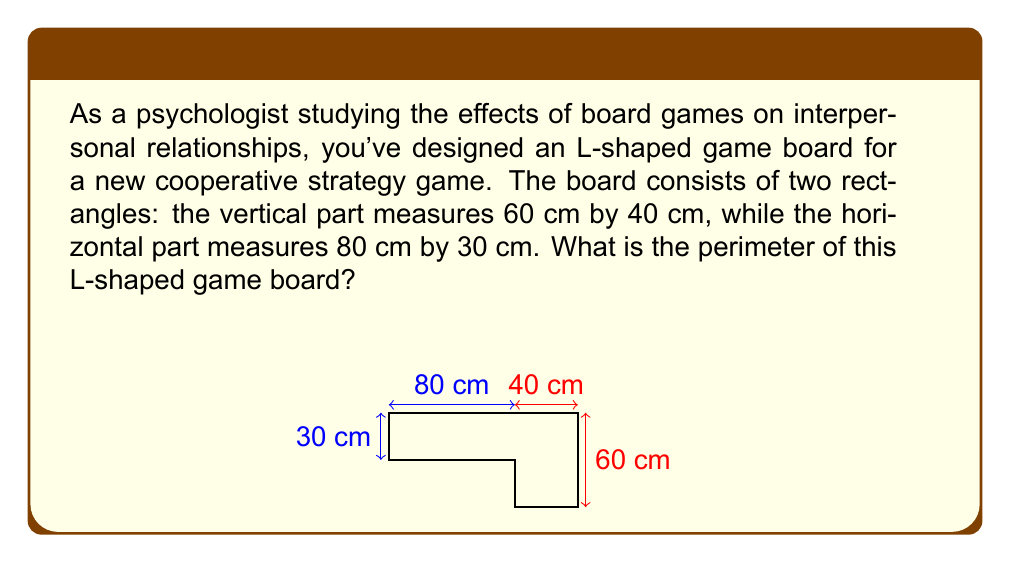Help me with this question. To find the perimeter of the L-shaped game board, we need to calculate the sum of all outer edges. Let's break this down step-by-step:

1) First, let's identify the edges we need to add:
   - The left side of the vertical rectangle
   - The top of both rectangles
   - The right side of the vertical rectangle
   - The bottom of the horizontal rectangle
   - The right side of the horizontal rectangle

2) Now, let's add these lengths:
   $$ \text{Perimeter} = 60 \text{ cm} + 40 \text{ cm} + 80 \text{ cm} + 30 \text{ cm} + 30 \text{ cm} $$

3) Simplifying:
   $$ \text{Perimeter} = 240 \text{ cm} $$

4) We can also express this in meters:
   $$ \text{Perimeter} = 2.4 \text{ m} $$

This L-shaped design could be interesting from a psychological perspective, as it might encourage players to move around the board more, potentially increasing interaction and communication between players.
Answer: The perimeter of the L-shaped game board is 240 cm or 2.4 m. 